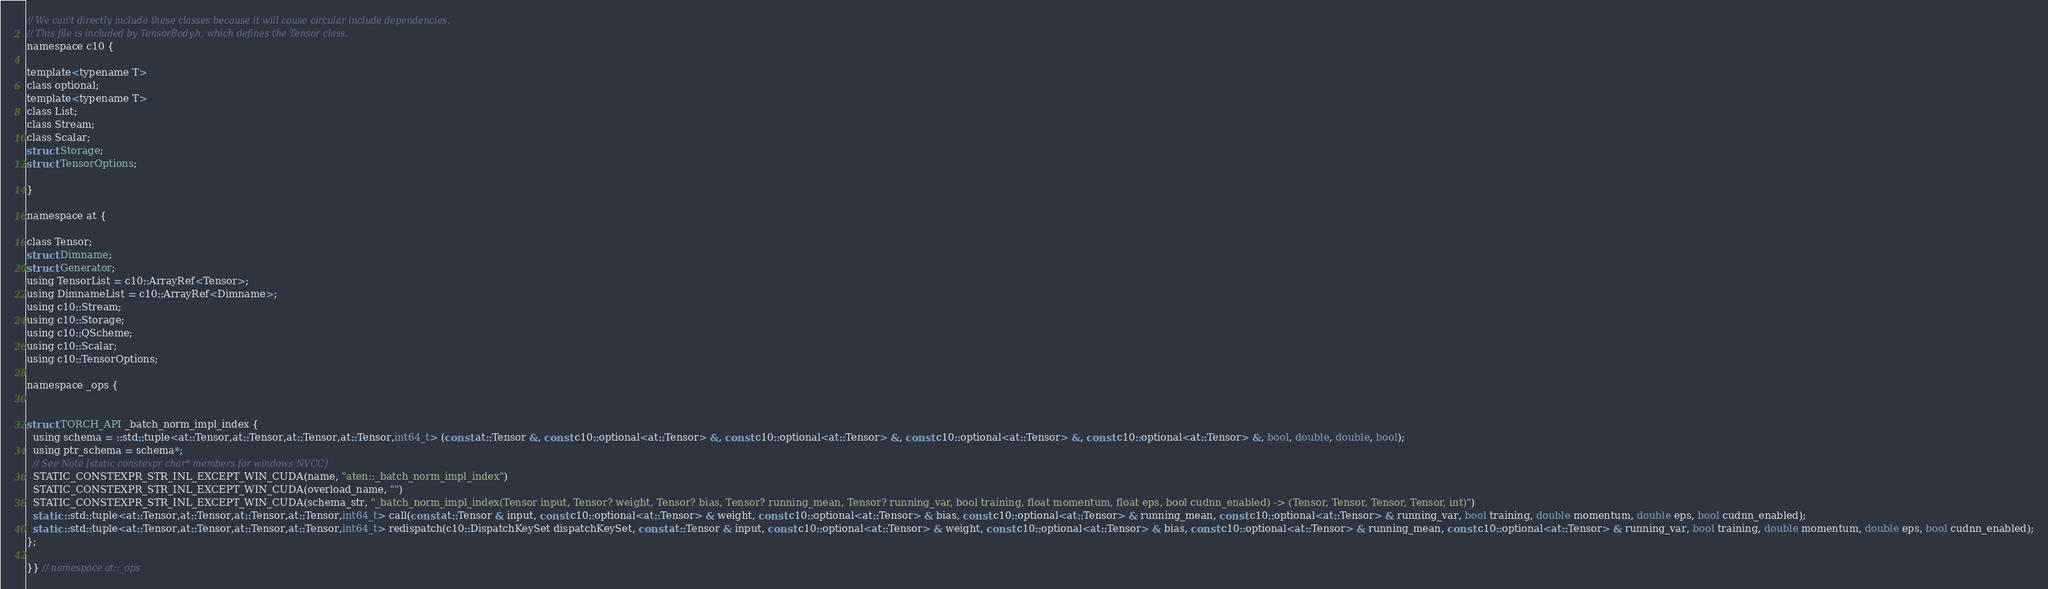<code> <loc_0><loc_0><loc_500><loc_500><_C_>// We can't directly include these classes because it will cause circular include dependencies.
// This file is included by TensorBody.h, which defines the Tensor class.
namespace c10 {

template<typename T>
class optional;
template<typename T>
class List;
class Stream;
class Scalar;
struct Storage;
struct TensorOptions;

}

namespace at {

class Tensor;
struct Dimname;
struct Generator;
using TensorList = c10::ArrayRef<Tensor>;
using DimnameList = c10::ArrayRef<Dimname>;
using c10::Stream;
using c10::Storage;
using c10::QScheme;
using c10::Scalar;
using c10::TensorOptions;

namespace _ops {


struct TORCH_API _batch_norm_impl_index {
  using schema = ::std::tuple<at::Tensor,at::Tensor,at::Tensor,at::Tensor,int64_t> (const at::Tensor &, const c10::optional<at::Tensor> &, const c10::optional<at::Tensor> &, const c10::optional<at::Tensor> &, const c10::optional<at::Tensor> &, bool, double, double, bool);
  using ptr_schema = schema*;
  // See Note [static constexpr char* members for windows NVCC]
  STATIC_CONSTEXPR_STR_INL_EXCEPT_WIN_CUDA(name, "aten::_batch_norm_impl_index")
  STATIC_CONSTEXPR_STR_INL_EXCEPT_WIN_CUDA(overload_name, "")
  STATIC_CONSTEXPR_STR_INL_EXCEPT_WIN_CUDA(schema_str, "_batch_norm_impl_index(Tensor input, Tensor? weight, Tensor? bias, Tensor? running_mean, Tensor? running_var, bool training, float momentum, float eps, bool cudnn_enabled) -> (Tensor, Tensor, Tensor, Tensor, int)")
  static ::std::tuple<at::Tensor,at::Tensor,at::Tensor,at::Tensor,int64_t> call(const at::Tensor & input, const c10::optional<at::Tensor> & weight, const c10::optional<at::Tensor> & bias, const c10::optional<at::Tensor> & running_mean, const c10::optional<at::Tensor> & running_var, bool training, double momentum, double eps, bool cudnn_enabled);
  static ::std::tuple<at::Tensor,at::Tensor,at::Tensor,at::Tensor,int64_t> redispatch(c10::DispatchKeySet dispatchKeySet, const at::Tensor & input, const c10::optional<at::Tensor> & weight, const c10::optional<at::Tensor> & bias, const c10::optional<at::Tensor> & running_mean, const c10::optional<at::Tensor> & running_var, bool training, double momentum, double eps, bool cudnn_enabled);
};

}} // namespace at::_ops
</code> 